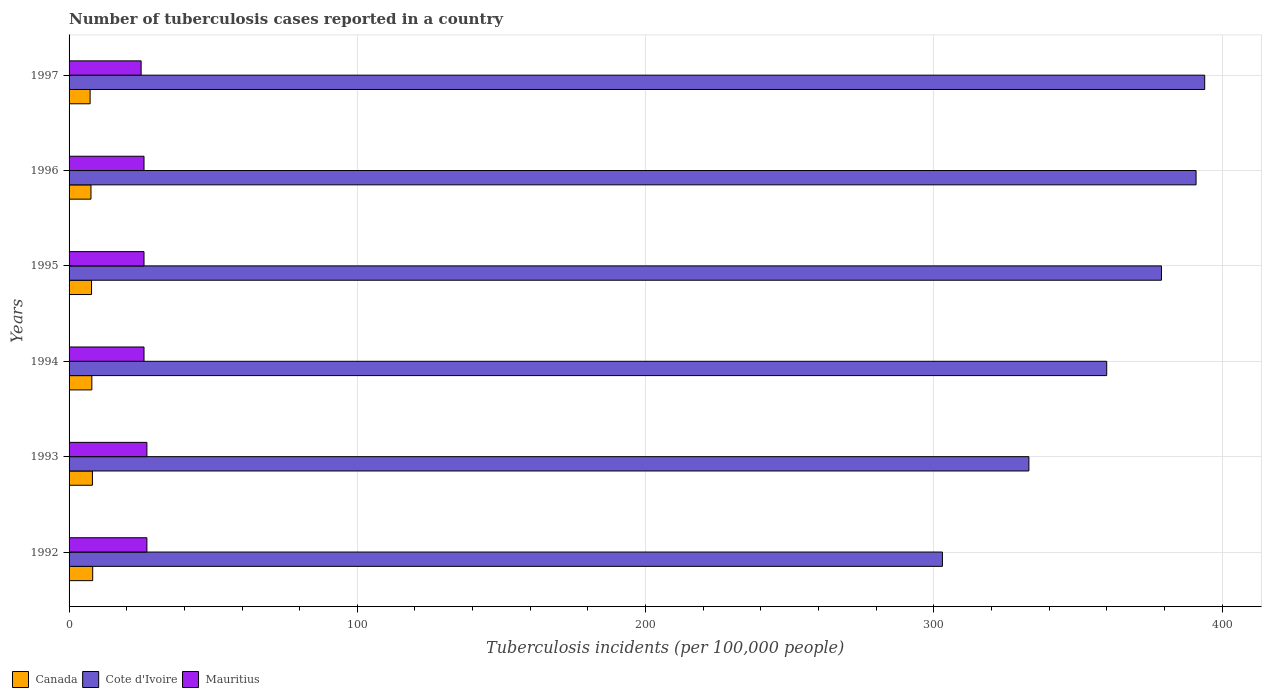How many different coloured bars are there?
Your response must be concise. 3. Are the number of bars per tick equal to the number of legend labels?
Keep it short and to the point. Yes. How many bars are there on the 1st tick from the top?
Give a very brief answer. 3. How many bars are there on the 3rd tick from the bottom?
Offer a very short reply. 3. What is the label of the 4th group of bars from the top?
Provide a succinct answer. 1994. In how many cases, is the number of bars for a given year not equal to the number of legend labels?
Provide a succinct answer. 0. What is the number of tuberculosis cases reported in in Cote d'Ivoire in 1992?
Your response must be concise. 303. Across all years, what is the maximum number of tuberculosis cases reported in in Canada?
Keep it short and to the point. 8.2. Across all years, what is the minimum number of tuberculosis cases reported in in Mauritius?
Provide a short and direct response. 25. In which year was the number of tuberculosis cases reported in in Canada maximum?
Ensure brevity in your answer.  1992. What is the total number of tuberculosis cases reported in in Cote d'Ivoire in the graph?
Your answer should be compact. 2160. What is the difference between the number of tuberculosis cases reported in in Canada in 1992 and that in 1993?
Your answer should be very brief. 0.1. What is the difference between the number of tuberculosis cases reported in in Cote d'Ivoire in 1993 and the number of tuberculosis cases reported in in Canada in 1997?
Make the answer very short. 325.7. What is the average number of tuberculosis cases reported in in Mauritius per year?
Offer a terse response. 26.17. In the year 1993, what is the difference between the number of tuberculosis cases reported in in Cote d'Ivoire and number of tuberculosis cases reported in in Canada?
Make the answer very short. 324.9. In how many years, is the number of tuberculosis cases reported in in Canada greater than 280 ?
Give a very brief answer. 0. What is the ratio of the number of tuberculosis cases reported in in Mauritius in 1993 to that in 1995?
Provide a succinct answer. 1.04. Is the number of tuberculosis cases reported in in Mauritius in 1993 less than that in 1994?
Offer a terse response. No. What is the difference between the highest and the second highest number of tuberculosis cases reported in in Canada?
Give a very brief answer. 0.1. What is the difference between the highest and the lowest number of tuberculosis cases reported in in Cote d'Ivoire?
Your response must be concise. 91. In how many years, is the number of tuberculosis cases reported in in Cote d'Ivoire greater than the average number of tuberculosis cases reported in in Cote d'Ivoire taken over all years?
Offer a terse response. 3. What does the 1st bar from the top in 1992 represents?
Keep it short and to the point. Mauritius. What does the 3rd bar from the bottom in 1995 represents?
Give a very brief answer. Mauritius. Is it the case that in every year, the sum of the number of tuberculosis cases reported in in Canada and number of tuberculosis cases reported in in Mauritius is greater than the number of tuberculosis cases reported in in Cote d'Ivoire?
Ensure brevity in your answer.  No. How many bars are there?
Make the answer very short. 18. What is the difference between two consecutive major ticks on the X-axis?
Provide a succinct answer. 100. Does the graph contain any zero values?
Give a very brief answer. No. Does the graph contain grids?
Ensure brevity in your answer.  Yes. How many legend labels are there?
Give a very brief answer. 3. What is the title of the graph?
Ensure brevity in your answer.  Number of tuberculosis cases reported in a country. Does "Tajikistan" appear as one of the legend labels in the graph?
Offer a very short reply. No. What is the label or title of the X-axis?
Your answer should be very brief. Tuberculosis incidents (per 100,0 people). What is the Tuberculosis incidents (per 100,000 people) in Cote d'Ivoire in 1992?
Your answer should be compact. 303. What is the Tuberculosis incidents (per 100,000 people) of Mauritius in 1992?
Your answer should be compact. 27. What is the Tuberculosis incidents (per 100,000 people) of Canada in 1993?
Make the answer very short. 8.1. What is the Tuberculosis incidents (per 100,000 people) of Cote d'Ivoire in 1993?
Keep it short and to the point. 333. What is the Tuberculosis incidents (per 100,000 people) of Canada in 1994?
Offer a very short reply. 7.9. What is the Tuberculosis incidents (per 100,000 people) in Cote d'Ivoire in 1994?
Provide a succinct answer. 360. What is the Tuberculosis incidents (per 100,000 people) of Mauritius in 1994?
Provide a short and direct response. 26. What is the Tuberculosis incidents (per 100,000 people) in Canada in 1995?
Give a very brief answer. 7.8. What is the Tuberculosis incidents (per 100,000 people) in Cote d'Ivoire in 1995?
Offer a terse response. 379. What is the Tuberculosis incidents (per 100,000 people) of Mauritius in 1995?
Keep it short and to the point. 26. What is the Tuberculosis incidents (per 100,000 people) in Cote d'Ivoire in 1996?
Provide a short and direct response. 391. What is the Tuberculosis incidents (per 100,000 people) in Canada in 1997?
Provide a short and direct response. 7.3. What is the Tuberculosis incidents (per 100,000 people) in Cote d'Ivoire in 1997?
Your response must be concise. 394. What is the Tuberculosis incidents (per 100,000 people) of Mauritius in 1997?
Keep it short and to the point. 25. Across all years, what is the maximum Tuberculosis incidents (per 100,000 people) in Canada?
Offer a very short reply. 8.2. Across all years, what is the maximum Tuberculosis incidents (per 100,000 people) of Cote d'Ivoire?
Your answer should be very brief. 394. Across all years, what is the maximum Tuberculosis incidents (per 100,000 people) in Mauritius?
Give a very brief answer. 27. Across all years, what is the minimum Tuberculosis incidents (per 100,000 people) in Cote d'Ivoire?
Provide a short and direct response. 303. Across all years, what is the minimum Tuberculosis incidents (per 100,000 people) in Mauritius?
Your answer should be compact. 25. What is the total Tuberculosis incidents (per 100,000 people) of Canada in the graph?
Give a very brief answer. 46.9. What is the total Tuberculosis incidents (per 100,000 people) in Cote d'Ivoire in the graph?
Offer a terse response. 2160. What is the total Tuberculosis incidents (per 100,000 people) in Mauritius in the graph?
Keep it short and to the point. 157. What is the difference between the Tuberculosis incidents (per 100,000 people) in Canada in 1992 and that in 1993?
Provide a succinct answer. 0.1. What is the difference between the Tuberculosis incidents (per 100,000 people) in Cote d'Ivoire in 1992 and that in 1993?
Provide a short and direct response. -30. What is the difference between the Tuberculosis incidents (per 100,000 people) of Canada in 1992 and that in 1994?
Provide a succinct answer. 0.3. What is the difference between the Tuberculosis incidents (per 100,000 people) in Cote d'Ivoire in 1992 and that in 1994?
Keep it short and to the point. -57. What is the difference between the Tuberculosis incidents (per 100,000 people) of Mauritius in 1992 and that in 1994?
Make the answer very short. 1. What is the difference between the Tuberculosis incidents (per 100,000 people) in Canada in 1992 and that in 1995?
Provide a short and direct response. 0.4. What is the difference between the Tuberculosis incidents (per 100,000 people) of Cote d'Ivoire in 1992 and that in 1995?
Provide a succinct answer. -76. What is the difference between the Tuberculosis incidents (per 100,000 people) in Cote d'Ivoire in 1992 and that in 1996?
Provide a succinct answer. -88. What is the difference between the Tuberculosis incidents (per 100,000 people) in Canada in 1992 and that in 1997?
Your answer should be compact. 0.9. What is the difference between the Tuberculosis incidents (per 100,000 people) in Cote d'Ivoire in 1992 and that in 1997?
Your response must be concise. -91. What is the difference between the Tuberculosis incidents (per 100,000 people) of Mauritius in 1992 and that in 1997?
Ensure brevity in your answer.  2. What is the difference between the Tuberculosis incidents (per 100,000 people) in Cote d'Ivoire in 1993 and that in 1994?
Your answer should be very brief. -27. What is the difference between the Tuberculosis incidents (per 100,000 people) in Cote d'Ivoire in 1993 and that in 1995?
Your answer should be very brief. -46. What is the difference between the Tuberculosis incidents (per 100,000 people) in Canada in 1993 and that in 1996?
Make the answer very short. 0.5. What is the difference between the Tuberculosis incidents (per 100,000 people) of Cote d'Ivoire in 1993 and that in 1996?
Make the answer very short. -58. What is the difference between the Tuberculosis incidents (per 100,000 people) in Mauritius in 1993 and that in 1996?
Make the answer very short. 1. What is the difference between the Tuberculosis incidents (per 100,000 people) of Cote d'Ivoire in 1993 and that in 1997?
Offer a terse response. -61. What is the difference between the Tuberculosis incidents (per 100,000 people) in Canada in 1994 and that in 1995?
Give a very brief answer. 0.1. What is the difference between the Tuberculosis incidents (per 100,000 people) in Cote d'Ivoire in 1994 and that in 1995?
Ensure brevity in your answer.  -19. What is the difference between the Tuberculosis incidents (per 100,000 people) of Cote d'Ivoire in 1994 and that in 1996?
Ensure brevity in your answer.  -31. What is the difference between the Tuberculosis incidents (per 100,000 people) in Canada in 1994 and that in 1997?
Provide a short and direct response. 0.6. What is the difference between the Tuberculosis incidents (per 100,000 people) of Cote d'Ivoire in 1994 and that in 1997?
Make the answer very short. -34. What is the difference between the Tuberculosis incidents (per 100,000 people) of Mauritius in 1994 and that in 1997?
Make the answer very short. 1. What is the difference between the Tuberculosis incidents (per 100,000 people) of Canada in 1995 and that in 1996?
Ensure brevity in your answer.  0.2. What is the difference between the Tuberculosis incidents (per 100,000 people) in Mauritius in 1995 and that in 1996?
Provide a succinct answer. 0. What is the difference between the Tuberculosis incidents (per 100,000 people) of Canada in 1995 and that in 1997?
Offer a terse response. 0.5. What is the difference between the Tuberculosis incidents (per 100,000 people) in Canada in 1992 and the Tuberculosis incidents (per 100,000 people) in Cote d'Ivoire in 1993?
Offer a terse response. -324.8. What is the difference between the Tuberculosis incidents (per 100,000 people) in Canada in 1992 and the Tuberculosis incidents (per 100,000 people) in Mauritius in 1993?
Give a very brief answer. -18.8. What is the difference between the Tuberculosis incidents (per 100,000 people) of Cote d'Ivoire in 1992 and the Tuberculosis incidents (per 100,000 people) of Mauritius in 1993?
Your response must be concise. 276. What is the difference between the Tuberculosis incidents (per 100,000 people) in Canada in 1992 and the Tuberculosis incidents (per 100,000 people) in Cote d'Ivoire in 1994?
Provide a short and direct response. -351.8. What is the difference between the Tuberculosis incidents (per 100,000 people) of Canada in 1992 and the Tuberculosis incidents (per 100,000 people) of Mauritius in 1994?
Your answer should be compact. -17.8. What is the difference between the Tuberculosis incidents (per 100,000 people) in Cote d'Ivoire in 1992 and the Tuberculosis incidents (per 100,000 people) in Mauritius in 1994?
Offer a very short reply. 277. What is the difference between the Tuberculosis incidents (per 100,000 people) of Canada in 1992 and the Tuberculosis incidents (per 100,000 people) of Cote d'Ivoire in 1995?
Keep it short and to the point. -370.8. What is the difference between the Tuberculosis incidents (per 100,000 people) in Canada in 1992 and the Tuberculosis incidents (per 100,000 people) in Mauritius in 1995?
Give a very brief answer. -17.8. What is the difference between the Tuberculosis incidents (per 100,000 people) of Cote d'Ivoire in 1992 and the Tuberculosis incidents (per 100,000 people) of Mauritius in 1995?
Keep it short and to the point. 277. What is the difference between the Tuberculosis incidents (per 100,000 people) of Canada in 1992 and the Tuberculosis incidents (per 100,000 people) of Cote d'Ivoire in 1996?
Your answer should be very brief. -382.8. What is the difference between the Tuberculosis incidents (per 100,000 people) in Canada in 1992 and the Tuberculosis incidents (per 100,000 people) in Mauritius in 1996?
Your answer should be very brief. -17.8. What is the difference between the Tuberculosis incidents (per 100,000 people) of Cote d'Ivoire in 1992 and the Tuberculosis incidents (per 100,000 people) of Mauritius in 1996?
Offer a very short reply. 277. What is the difference between the Tuberculosis incidents (per 100,000 people) of Canada in 1992 and the Tuberculosis incidents (per 100,000 people) of Cote d'Ivoire in 1997?
Your answer should be compact. -385.8. What is the difference between the Tuberculosis incidents (per 100,000 people) in Canada in 1992 and the Tuberculosis incidents (per 100,000 people) in Mauritius in 1997?
Provide a short and direct response. -16.8. What is the difference between the Tuberculosis incidents (per 100,000 people) of Cote d'Ivoire in 1992 and the Tuberculosis incidents (per 100,000 people) of Mauritius in 1997?
Provide a succinct answer. 278. What is the difference between the Tuberculosis incidents (per 100,000 people) in Canada in 1993 and the Tuberculosis incidents (per 100,000 people) in Cote d'Ivoire in 1994?
Ensure brevity in your answer.  -351.9. What is the difference between the Tuberculosis incidents (per 100,000 people) in Canada in 1993 and the Tuberculosis incidents (per 100,000 people) in Mauritius in 1994?
Your answer should be very brief. -17.9. What is the difference between the Tuberculosis incidents (per 100,000 people) in Cote d'Ivoire in 1993 and the Tuberculosis incidents (per 100,000 people) in Mauritius in 1994?
Provide a succinct answer. 307. What is the difference between the Tuberculosis incidents (per 100,000 people) of Canada in 1993 and the Tuberculosis incidents (per 100,000 people) of Cote d'Ivoire in 1995?
Offer a very short reply. -370.9. What is the difference between the Tuberculosis incidents (per 100,000 people) in Canada in 1993 and the Tuberculosis incidents (per 100,000 people) in Mauritius in 1995?
Offer a terse response. -17.9. What is the difference between the Tuberculosis incidents (per 100,000 people) of Cote d'Ivoire in 1993 and the Tuberculosis incidents (per 100,000 people) of Mauritius in 1995?
Your answer should be compact. 307. What is the difference between the Tuberculosis incidents (per 100,000 people) of Canada in 1993 and the Tuberculosis incidents (per 100,000 people) of Cote d'Ivoire in 1996?
Ensure brevity in your answer.  -382.9. What is the difference between the Tuberculosis incidents (per 100,000 people) of Canada in 1993 and the Tuberculosis incidents (per 100,000 people) of Mauritius in 1996?
Provide a short and direct response. -17.9. What is the difference between the Tuberculosis incidents (per 100,000 people) of Cote d'Ivoire in 1993 and the Tuberculosis incidents (per 100,000 people) of Mauritius in 1996?
Your answer should be very brief. 307. What is the difference between the Tuberculosis incidents (per 100,000 people) of Canada in 1993 and the Tuberculosis incidents (per 100,000 people) of Cote d'Ivoire in 1997?
Provide a short and direct response. -385.9. What is the difference between the Tuberculosis incidents (per 100,000 people) in Canada in 1993 and the Tuberculosis incidents (per 100,000 people) in Mauritius in 1997?
Offer a very short reply. -16.9. What is the difference between the Tuberculosis incidents (per 100,000 people) of Cote d'Ivoire in 1993 and the Tuberculosis incidents (per 100,000 people) of Mauritius in 1997?
Provide a short and direct response. 308. What is the difference between the Tuberculosis incidents (per 100,000 people) of Canada in 1994 and the Tuberculosis incidents (per 100,000 people) of Cote d'Ivoire in 1995?
Provide a short and direct response. -371.1. What is the difference between the Tuberculosis incidents (per 100,000 people) of Canada in 1994 and the Tuberculosis incidents (per 100,000 people) of Mauritius in 1995?
Your response must be concise. -18.1. What is the difference between the Tuberculosis incidents (per 100,000 people) in Cote d'Ivoire in 1994 and the Tuberculosis incidents (per 100,000 people) in Mauritius in 1995?
Make the answer very short. 334. What is the difference between the Tuberculosis incidents (per 100,000 people) in Canada in 1994 and the Tuberculosis incidents (per 100,000 people) in Cote d'Ivoire in 1996?
Ensure brevity in your answer.  -383.1. What is the difference between the Tuberculosis incidents (per 100,000 people) in Canada in 1994 and the Tuberculosis incidents (per 100,000 people) in Mauritius in 1996?
Provide a short and direct response. -18.1. What is the difference between the Tuberculosis incidents (per 100,000 people) of Cote d'Ivoire in 1994 and the Tuberculosis incidents (per 100,000 people) of Mauritius in 1996?
Your answer should be compact. 334. What is the difference between the Tuberculosis incidents (per 100,000 people) of Canada in 1994 and the Tuberculosis incidents (per 100,000 people) of Cote d'Ivoire in 1997?
Your answer should be compact. -386.1. What is the difference between the Tuberculosis incidents (per 100,000 people) in Canada in 1994 and the Tuberculosis incidents (per 100,000 people) in Mauritius in 1997?
Offer a terse response. -17.1. What is the difference between the Tuberculosis incidents (per 100,000 people) of Cote d'Ivoire in 1994 and the Tuberculosis incidents (per 100,000 people) of Mauritius in 1997?
Make the answer very short. 335. What is the difference between the Tuberculosis incidents (per 100,000 people) in Canada in 1995 and the Tuberculosis incidents (per 100,000 people) in Cote d'Ivoire in 1996?
Your answer should be compact. -383.2. What is the difference between the Tuberculosis incidents (per 100,000 people) of Canada in 1995 and the Tuberculosis incidents (per 100,000 people) of Mauritius in 1996?
Provide a short and direct response. -18.2. What is the difference between the Tuberculosis incidents (per 100,000 people) in Cote d'Ivoire in 1995 and the Tuberculosis incidents (per 100,000 people) in Mauritius in 1996?
Your answer should be compact. 353. What is the difference between the Tuberculosis incidents (per 100,000 people) in Canada in 1995 and the Tuberculosis incidents (per 100,000 people) in Cote d'Ivoire in 1997?
Your response must be concise. -386.2. What is the difference between the Tuberculosis incidents (per 100,000 people) of Canada in 1995 and the Tuberculosis incidents (per 100,000 people) of Mauritius in 1997?
Offer a very short reply. -17.2. What is the difference between the Tuberculosis incidents (per 100,000 people) in Cote d'Ivoire in 1995 and the Tuberculosis incidents (per 100,000 people) in Mauritius in 1997?
Offer a very short reply. 354. What is the difference between the Tuberculosis incidents (per 100,000 people) in Canada in 1996 and the Tuberculosis incidents (per 100,000 people) in Cote d'Ivoire in 1997?
Give a very brief answer. -386.4. What is the difference between the Tuberculosis incidents (per 100,000 people) in Canada in 1996 and the Tuberculosis incidents (per 100,000 people) in Mauritius in 1997?
Your response must be concise. -17.4. What is the difference between the Tuberculosis incidents (per 100,000 people) of Cote d'Ivoire in 1996 and the Tuberculosis incidents (per 100,000 people) of Mauritius in 1997?
Provide a short and direct response. 366. What is the average Tuberculosis incidents (per 100,000 people) in Canada per year?
Give a very brief answer. 7.82. What is the average Tuberculosis incidents (per 100,000 people) of Cote d'Ivoire per year?
Keep it short and to the point. 360. What is the average Tuberculosis incidents (per 100,000 people) in Mauritius per year?
Provide a short and direct response. 26.17. In the year 1992, what is the difference between the Tuberculosis incidents (per 100,000 people) of Canada and Tuberculosis incidents (per 100,000 people) of Cote d'Ivoire?
Offer a very short reply. -294.8. In the year 1992, what is the difference between the Tuberculosis incidents (per 100,000 people) of Canada and Tuberculosis incidents (per 100,000 people) of Mauritius?
Offer a terse response. -18.8. In the year 1992, what is the difference between the Tuberculosis incidents (per 100,000 people) in Cote d'Ivoire and Tuberculosis incidents (per 100,000 people) in Mauritius?
Your answer should be very brief. 276. In the year 1993, what is the difference between the Tuberculosis incidents (per 100,000 people) of Canada and Tuberculosis incidents (per 100,000 people) of Cote d'Ivoire?
Provide a short and direct response. -324.9. In the year 1993, what is the difference between the Tuberculosis incidents (per 100,000 people) in Canada and Tuberculosis incidents (per 100,000 people) in Mauritius?
Your answer should be compact. -18.9. In the year 1993, what is the difference between the Tuberculosis incidents (per 100,000 people) of Cote d'Ivoire and Tuberculosis incidents (per 100,000 people) of Mauritius?
Give a very brief answer. 306. In the year 1994, what is the difference between the Tuberculosis incidents (per 100,000 people) of Canada and Tuberculosis incidents (per 100,000 people) of Cote d'Ivoire?
Ensure brevity in your answer.  -352.1. In the year 1994, what is the difference between the Tuberculosis incidents (per 100,000 people) in Canada and Tuberculosis incidents (per 100,000 people) in Mauritius?
Your answer should be very brief. -18.1. In the year 1994, what is the difference between the Tuberculosis incidents (per 100,000 people) in Cote d'Ivoire and Tuberculosis incidents (per 100,000 people) in Mauritius?
Your answer should be compact. 334. In the year 1995, what is the difference between the Tuberculosis incidents (per 100,000 people) of Canada and Tuberculosis incidents (per 100,000 people) of Cote d'Ivoire?
Give a very brief answer. -371.2. In the year 1995, what is the difference between the Tuberculosis incidents (per 100,000 people) of Canada and Tuberculosis incidents (per 100,000 people) of Mauritius?
Ensure brevity in your answer.  -18.2. In the year 1995, what is the difference between the Tuberculosis incidents (per 100,000 people) of Cote d'Ivoire and Tuberculosis incidents (per 100,000 people) of Mauritius?
Ensure brevity in your answer.  353. In the year 1996, what is the difference between the Tuberculosis incidents (per 100,000 people) of Canada and Tuberculosis incidents (per 100,000 people) of Cote d'Ivoire?
Give a very brief answer. -383.4. In the year 1996, what is the difference between the Tuberculosis incidents (per 100,000 people) of Canada and Tuberculosis incidents (per 100,000 people) of Mauritius?
Your answer should be compact. -18.4. In the year 1996, what is the difference between the Tuberculosis incidents (per 100,000 people) in Cote d'Ivoire and Tuberculosis incidents (per 100,000 people) in Mauritius?
Offer a terse response. 365. In the year 1997, what is the difference between the Tuberculosis incidents (per 100,000 people) of Canada and Tuberculosis incidents (per 100,000 people) of Cote d'Ivoire?
Offer a terse response. -386.7. In the year 1997, what is the difference between the Tuberculosis incidents (per 100,000 people) in Canada and Tuberculosis incidents (per 100,000 people) in Mauritius?
Provide a succinct answer. -17.7. In the year 1997, what is the difference between the Tuberculosis incidents (per 100,000 people) of Cote d'Ivoire and Tuberculosis incidents (per 100,000 people) of Mauritius?
Ensure brevity in your answer.  369. What is the ratio of the Tuberculosis incidents (per 100,000 people) of Canada in 1992 to that in 1993?
Make the answer very short. 1.01. What is the ratio of the Tuberculosis incidents (per 100,000 people) in Cote d'Ivoire in 1992 to that in 1993?
Your answer should be compact. 0.91. What is the ratio of the Tuberculosis incidents (per 100,000 people) of Mauritius in 1992 to that in 1993?
Give a very brief answer. 1. What is the ratio of the Tuberculosis incidents (per 100,000 people) in Canada in 1992 to that in 1994?
Keep it short and to the point. 1.04. What is the ratio of the Tuberculosis incidents (per 100,000 people) in Cote d'Ivoire in 1992 to that in 1994?
Give a very brief answer. 0.84. What is the ratio of the Tuberculosis incidents (per 100,000 people) in Canada in 1992 to that in 1995?
Provide a succinct answer. 1.05. What is the ratio of the Tuberculosis incidents (per 100,000 people) in Cote d'Ivoire in 1992 to that in 1995?
Keep it short and to the point. 0.8. What is the ratio of the Tuberculosis incidents (per 100,000 people) in Canada in 1992 to that in 1996?
Offer a very short reply. 1.08. What is the ratio of the Tuberculosis incidents (per 100,000 people) of Cote d'Ivoire in 1992 to that in 1996?
Make the answer very short. 0.77. What is the ratio of the Tuberculosis incidents (per 100,000 people) of Canada in 1992 to that in 1997?
Your answer should be very brief. 1.12. What is the ratio of the Tuberculosis incidents (per 100,000 people) of Cote d'Ivoire in 1992 to that in 1997?
Make the answer very short. 0.77. What is the ratio of the Tuberculosis incidents (per 100,000 people) of Mauritius in 1992 to that in 1997?
Make the answer very short. 1.08. What is the ratio of the Tuberculosis incidents (per 100,000 people) of Canada in 1993 to that in 1994?
Give a very brief answer. 1.03. What is the ratio of the Tuberculosis incidents (per 100,000 people) in Cote d'Ivoire in 1993 to that in 1994?
Provide a succinct answer. 0.93. What is the ratio of the Tuberculosis incidents (per 100,000 people) of Mauritius in 1993 to that in 1994?
Give a very brief answer. 1.04. What is the ratio of the Tuberculosis incidents (per 100,000 people) in Canada in 1993 to that in 1995?
Give a very brief answer. 1.04. What is the ratio of the Tuberculosis incidents (per 100,000 people) of Cote d'Ivoire in 1993 to that in 1995?
Ensure brevity in your answer.  0.88. What is the ratio of the Tuberculosis incidents (per 100,000 people) in Mauritius in 1993 to that in 1995?
Offer a terse response. 1.04. What is the ratio of the Tuberculosis incidents (per 100,000 people) of Canada in 1993 to that in 1996?
Your response must be concise. 1.07. What is the ratio of the Tuberculosis incidents (per 100,000 people) in Cote d'Ivoire in 1993 to that in 1996?
Offer a terse response. 0.85. What is the ratio of the Tuberculosis incidents (per 100,000 people) of Mauritius in 1993 to that in 1996?
Offer a terse response. 1.04. What is the ratio of the Tuberculosis incidents (per 100,000 people) in Canada in 1993 to that in 1997?
Your answer should be compact. 1.11. What is the ratio of the Tuberculosis incidents (per 100,000 people) of Cote d'Ivoire in 1993 to that in 1997?
Your answer should be compact. 0.85. What is the ratio of the Tuberculosis incidents (per 100,000 people) in Canada in 1994 to that in 1995?
Provide a succinct answer. 1.01. What is the ratio of the Tuberculosis incidents (per 100,000 people) of Cote d'Ivoire in 1994 to that in 1995?
Provide a succinct answer. 0.95. What is the ratio of the Tuberculosis incidents (per 100,000 people) of Canada in 1994 to that in 1996?
Your answer should be compact. 1.04. What is the ratio of the Tuberculosis incidents (per 100,000 people) of Cote d'Ivoire in 1994 to that in 1996?
Provide a short and direct response. 0.92. What is the ratio of the Tuberculosis incidents (per 100,000 people) of Mauritius in 1994 to that in 1996?
Your answer should be very brief. 1. What is the ratio of the Tuberculosis incidents (per 100,000 people) in Canada in 1994 to that in 1997?
Provide a succinct answer. 1.08. What is the ratio of the Tuberculosis incidents (per 100,000 people) of Cote d'Ivoire in 1994 to that in 1997?
Keep it short and to the point. 0.91. What is the ratio of the Tuberculosis incidents (per 100,000 people) in Canada in 1995 to that in 1996?
Ensure brevity in your answer.  1.03. What is the ratio of the Tuberculosis incidents (per 100,000 people) in Cote d'Ivoire in 1995 to that in 1996?
Provide a short and direct response. 0.97. What is the ratio of the Tuberculosis incidents (per 100,000 people) in Mauritius in 1995 to that in 1996?
Offer a terse response. 1. What is the ratio of the Tuberculosis incidents (per 100,000 people) in Canada in 1995 to that in 1997?
Make the answer very short. 1.07. What is the ratio of the Tuberculosis incidents (per 100,000 people) in Cote d'Ivoire in 1995 to that in 1997?
Keep it short and to the point. 0.96. What is the ratio of the Tuberculosis incidents (per 100,000 people) of Canada in 1996 to that in 1997?
Provide a short and direct response. 1.04. What is the ratio of the Tuberculosis incidents (per 100,000 people) of Mauritius in 1996 to that in 1997?
Make the answer very short. 1.04. What is the difference between the highest and the second highest Tuberculosis incidents (per 100,000 people) of Cote d'Ivoire?
Keep it short and to the point. 3. What is the difference between the highest and the lowest Tuberculosis incidents (per 100,000 people) in Cote d'Ivoire?
Keep it short and to the point. 91. What is the difference between the highest and the lowest Tuberculosis incidents (per 100,000 people) of Mauritius?
Offer a very short reply. 2. 